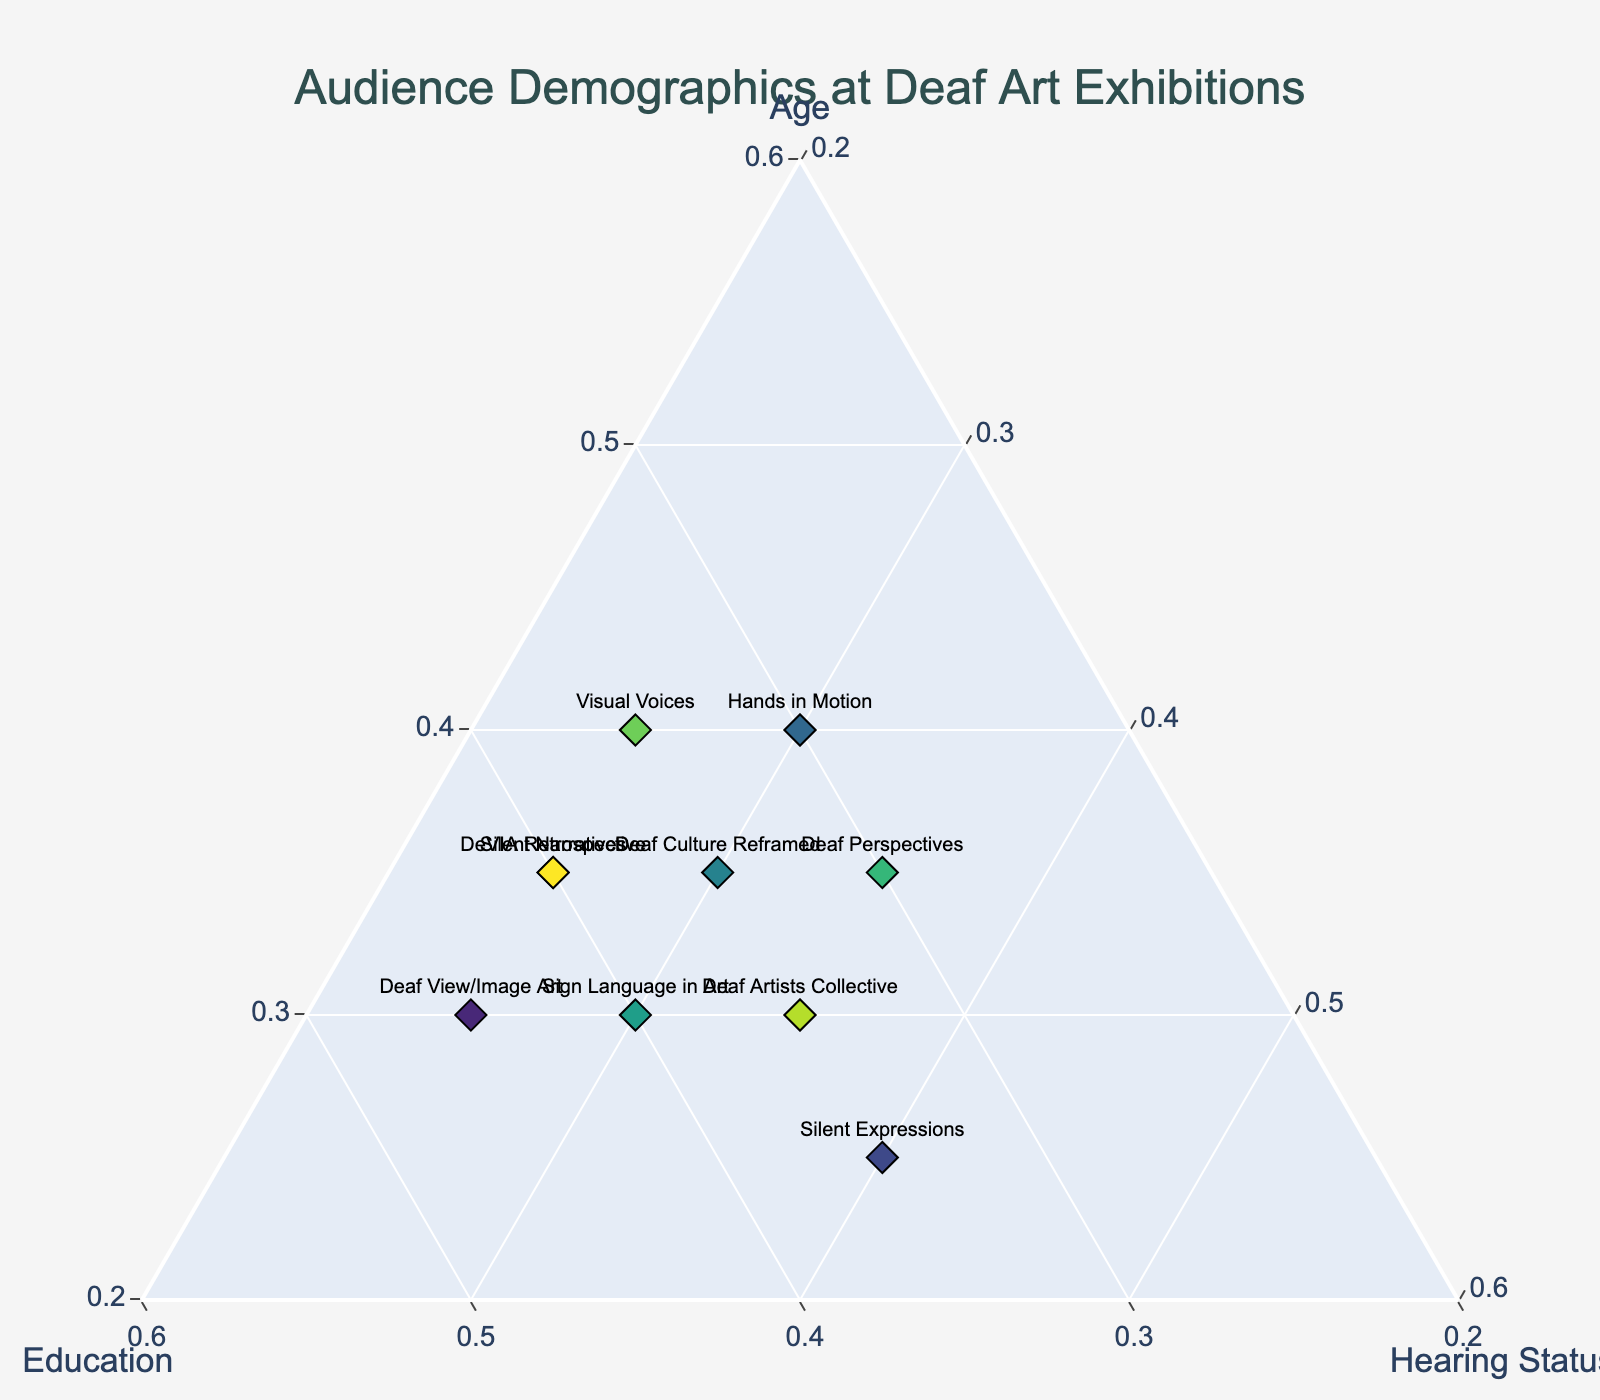Which exhibition attracts the most visitors based on age? By observing the ternary plot, look for the point located closest to the corner labeled "Age". This point represents the largest proportion of visitors based on age.
Answer: Hands in Motion What is the title of the figure? The title is usually prominently displayed at the top center of the plot, making it easily identifiable.
Answer: Audience Demographics at Deaf Art Exhibitions Which exhibitions have the same proportion of hearing visitors? Check the proximity of the points to the "Hearing Status" axis and compare their positions. The exhibitions "DeVIA Retrospective," "Deaf View/Image Art," and "Silent Narratives" all line up with 25% on the Hearing Status axis.
Answer: DeVIA Retrospective, Deaf View/Image Art, Silent Narratives Which exhibition has the most balanced demographics between age, education, and hearing status? Find the point that forms a roughly equilateral triangle within the ternary plot, indicating balanced proportions among the three categories.
Answer: Deaf Culture Reframed What is the axis range for the "Education" category? The axis range is provided along the "Education" side of the ternary plot, typically between 0 and 1 or 0 and 100%.
Answer: 0.2 - 1 How many exhibitions are represented in the plot? Count the number of distinct points plotted on the ternary plot. Each point represents one exhibition.
Answer: 10 Which two exhibitions have the closest proportions of visiting groups based on age? Examine the distances between points along the "Age" axis to find the two that are closest to each other.
Answer: Silent Expressions and Visual Voices What is the most noticeable trend in the audience demographics at these exhibitions? Look for clusters or patterns in the ternary plot data points to identify any trends, such as whether most exhibitions have a similar proportion of visitors by education or hearing status.
Answer: Predominantly balanced with a slight tilt towards Age and Education Which exhibition has the highest proportion of visitors from an educational background? Identify the point closest to the "Education" corner of the ternary plot.
Answer: Deaf View/Image Art Compare the demographics of "DeVIA Retrospective" and "Deaf Perspectives" in terms of hearing status. Which has a higher proportion? Identify the position of the two points corresponding to these exhibitions along the "Hearing Status" axis, and compare.
Answer: Deaf Perspectives 